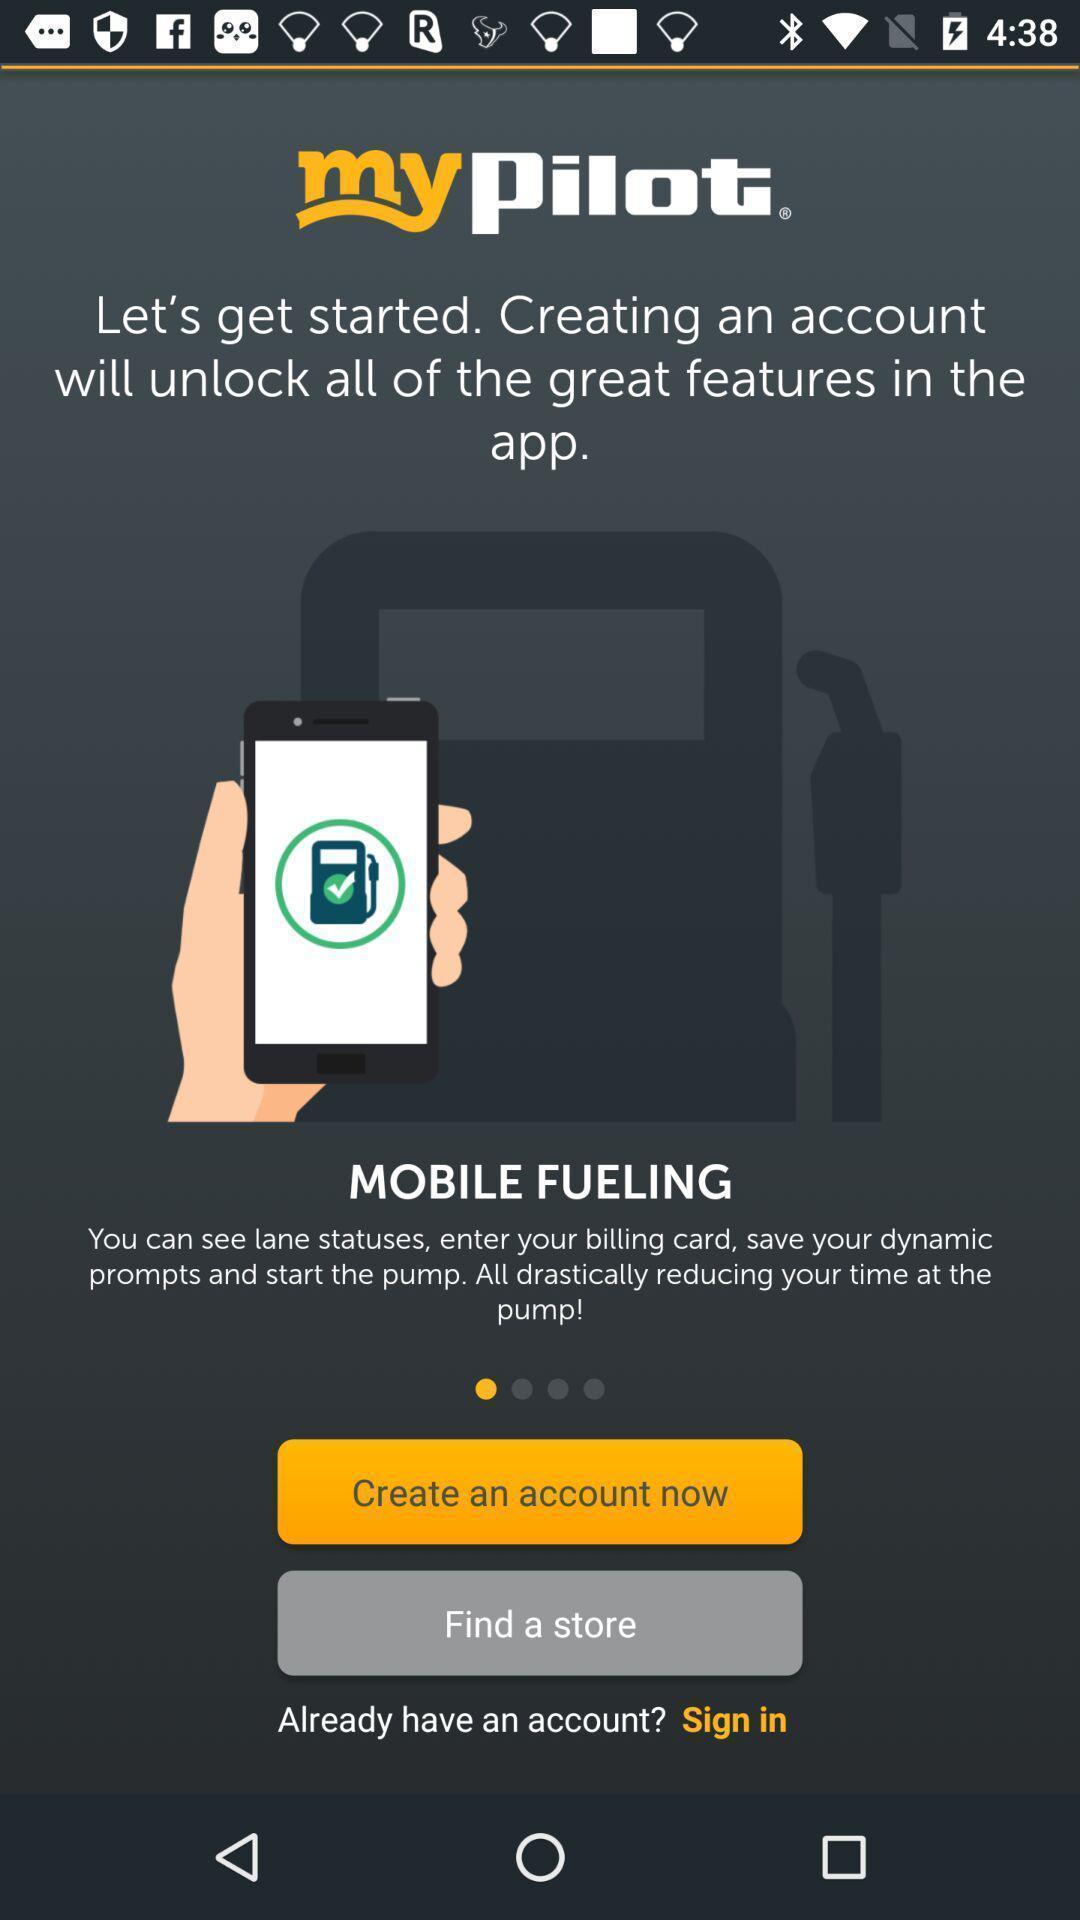Describe the visual elements of this screenshot. Page with create an account now option. 